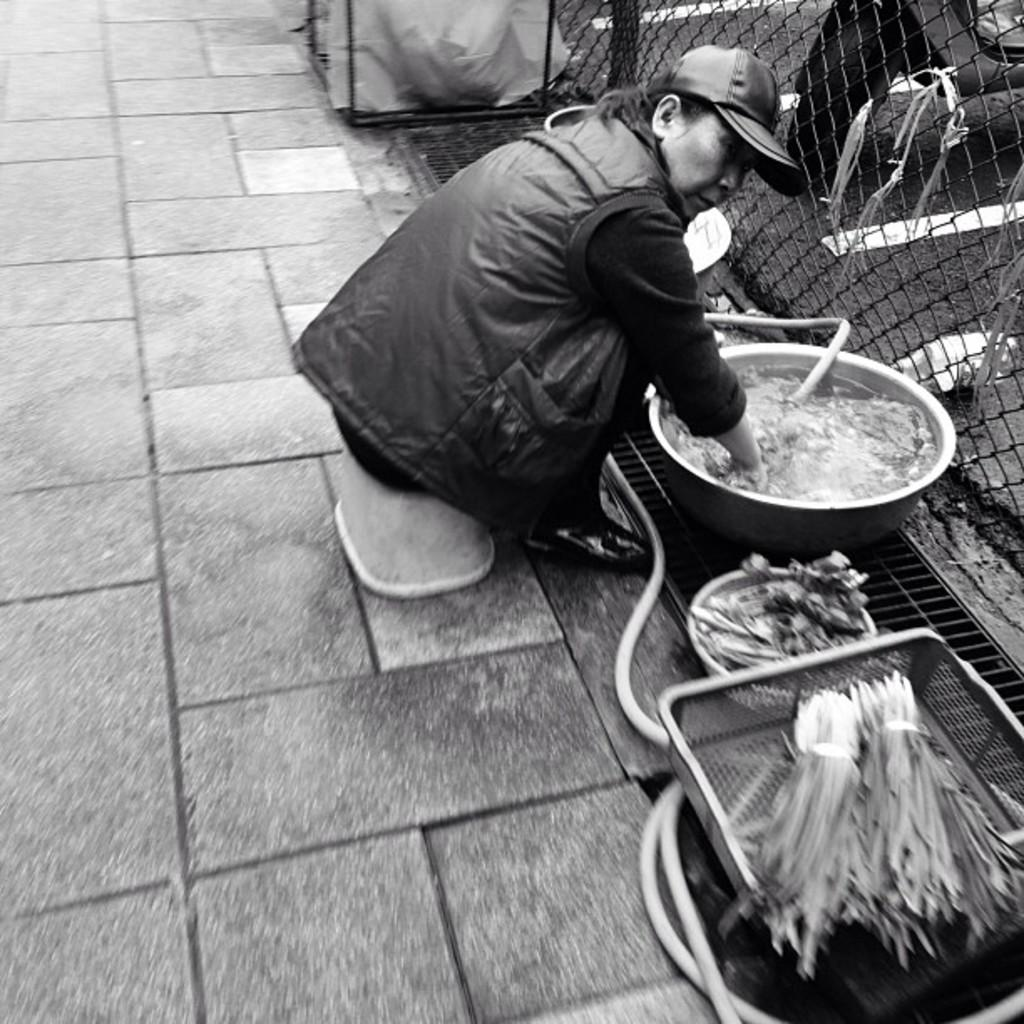Who is present in the image? There is a woman in the image. What is the woman doing in the image? The woman is sitting and mixing something in a bowl. What type of ingredients can be seen in the image? There are vegetables in the image. What is visible in the background of the image? There is a fence in the image. What type of flame can be seen coming from the woman's hand in the image? There is no flame present in the image; the woman is mixing something in a bowl. How many people are pushing the fence in the image? There are no people pushing the fence in the image; the fence is simply visible in the background. 